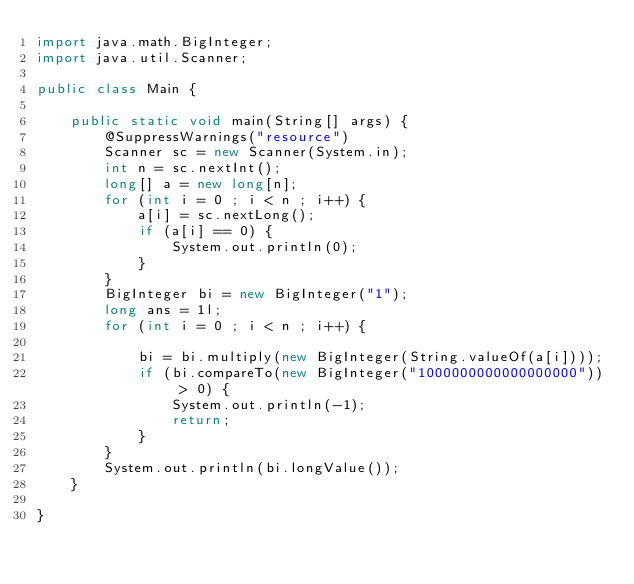<code> <loc_0><loc_0><loc_500><loc_500><_Java_>import java.math.BigInteger;
import java.util.Scanner;

public class Main {

    public static void main(String[] args) {
        @SuppressWarnings("resource")
        Scanner sc = new Scanner(System.in);
        int n = sc.nextInt();
        long[] a = new long[n];
        for (int i = 0 ; i < n ; i++) {
            a[i] = sc.nextLong();
            if (a[i] == 0) {
                System.out.println(0);
            }
        }
        BigInteger bi = new BigInteger("1");
        long ans = 1l;
        for (int i = 0 ; i < n ; i++) {

            bi = bi.multiply(new BigInteger(String.valueOf(a[i])));
            if (bi.compareTo(new BigInteger("1000000000000000000")) > 0) {
                System.out.println(-1);
                return;
            }
        }
        System.out.println(bi.longValue());
    }

}
</code> 